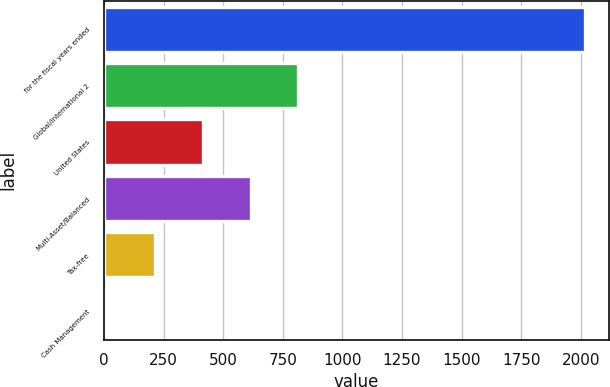<chart> <loc_0><loc_0><loc_500><loc_500><bar_chart><fcel>for the fiscal years ended<fcel>Global/international 2<fcel>United States<fcel>Multi-Asset/Balanced<fcel>Tax-free<fcel>Cash Management<nl><fcel>2017<fcel>815.8<fcel>415.4<fcel>615.6<fcel>215.2<fcel>15<nl></chart> 